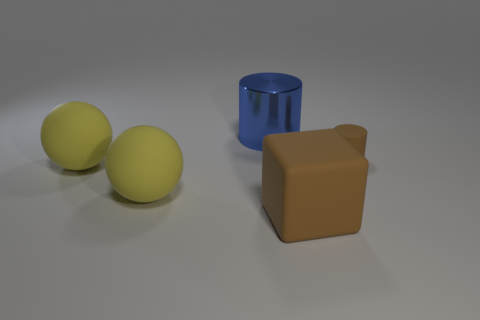Subtract all brown cylinders. Subtract all brown balls. How many cylinders are left? 1 Add 4 cylinders. How many objects exist? 9 Subtract all cylinders. How many objects are left? 3 Add 5 big matte objects. How many big matte objects are left? 8 Add 1 metallic cylinders. How many metallic cylinders exist? 2 Subtract 0 cyan spheres. How many objects are left? 5 Subtract all tiny red metal spheres. Subtract all tiny cylinders. How many objects are left? 4 